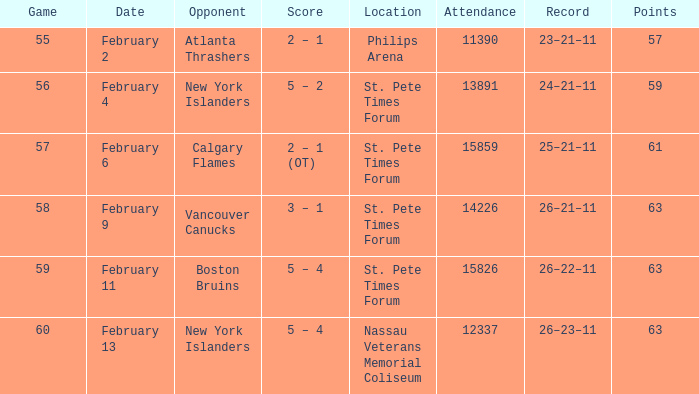What scores happened on February 9? 3 – 1. 